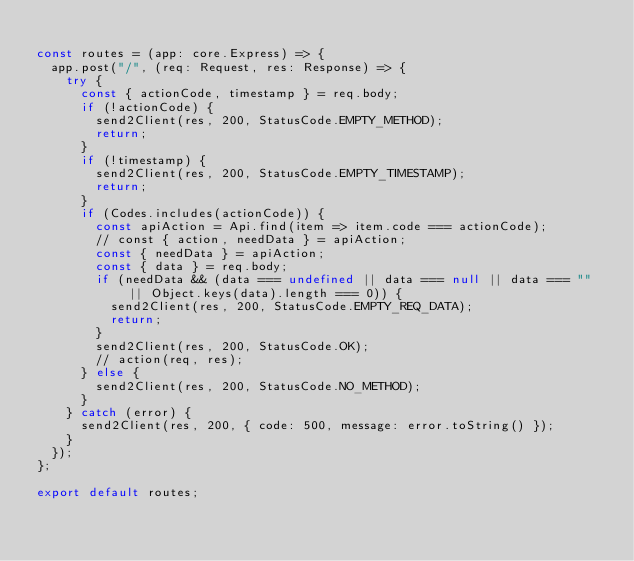Convert code to text. <code><loc_0><loc_0><loc_500><loc_500><_TypeScript_>
const routes = (app: core.Express) => {
  app.post("/", (req: Request, res: Response) => {
    try {
      const { actionCode, timestamp } = req.body;
      if (!actionCode) {
        send2Client(res, 200, StatusCode.EMPTY_METHOD);
        return;
      }
      if (!timestamp) {
        send2Client(res, 200, StatusCode.EMPTY_TIMESTAMP);
        return;
      }
      if (Codes.includes(actionCode)) {
        const apiAction = Api.find(item => item.code === actionCode);
        // const { action, needData } = apiAction;
        const { needData } = apiAction;
        const { data } = req.body;
        if (needData && (data === undefined || data === null || data === "" || Object.keys(data).length === 0)) {
          send2Client(res, 200, StatusCode.EMPTY_REQ_DATA);
          return;
        }
        send2Client(res, 200, StatusCode.OK);
        // action(req, res);
      } else {
        send2Client(res, 200, StatusCode.NO_METHOD);
      }
    } catch (error) {
      send2Client(res, 200, { code: 500, message: error.toString() });
    }
  });
};

export default routes;
</code> 